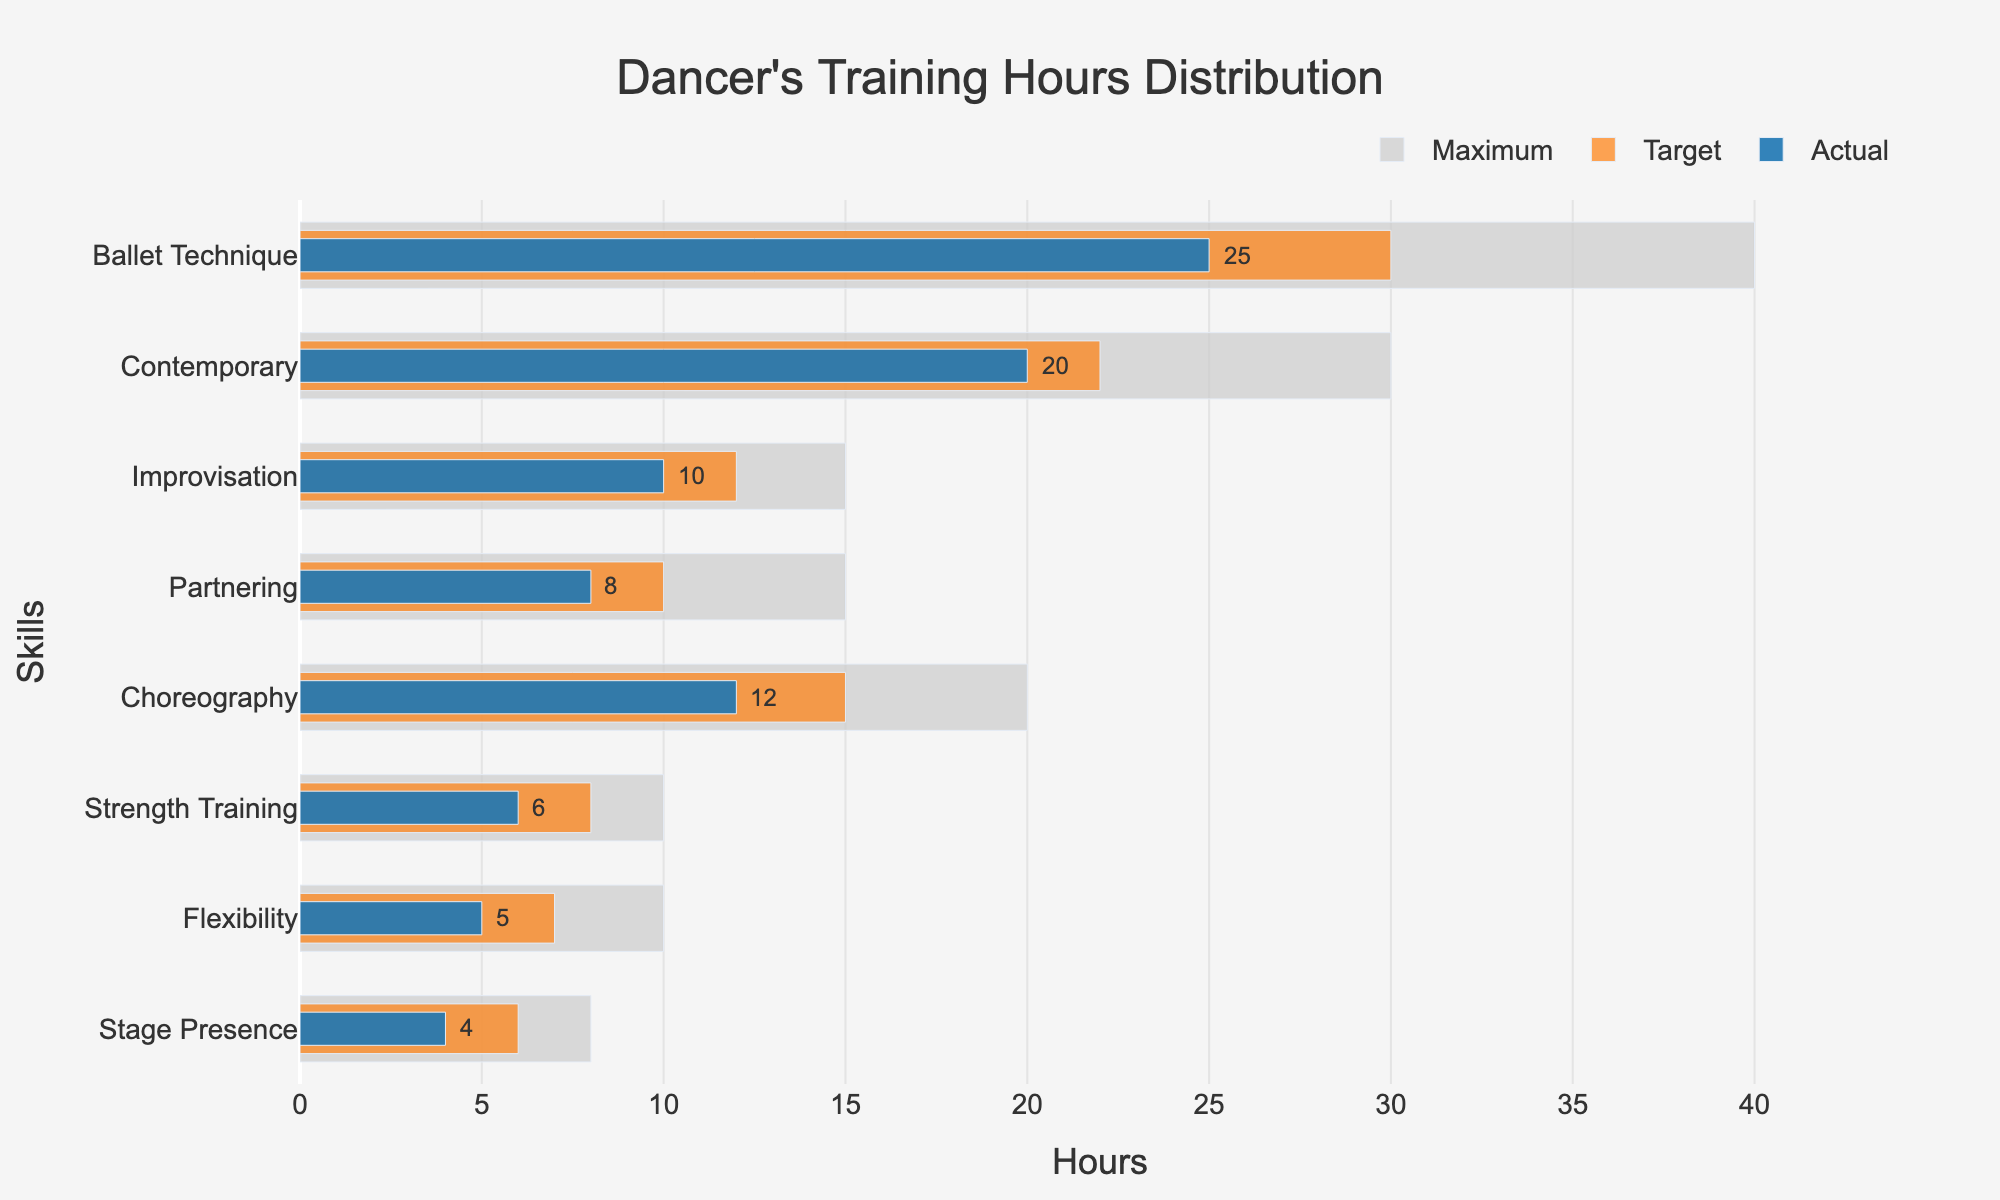What's the title of the figure? The title is located at the top center of the figure. It provides a summary of what the figure represents.
Answer: Dancer's Training Hours Distribution What are the skills evaluated in the figure? The skills are listed along the y-axis of the figure. You can read them from top to bottom.
Answer: Ballet Technique, Contemporary, Improvisation, Partnering, Choreography, Strength Training, Flexibility, Stage Presence Which skill has the highest target training hours? To determine this, look at the orange bars representing the target values and identify which bar is the longest.
Answer: Ballet Technique What is the difference between the actual and target training hours for Partnering? To calculate the difference, subtract the actual hours from the target hours for Partnering (10 - 8).
Answer: 2 How many training hours are dedicated to Strength Training in reality? Referring to the actual values (blue bars) for Strength Training, you can see how many hours are actually dedicated.
Answer: 6 How do the actual training hours for Stage Presence compare to its maximum possible value? Compare the blue bar (actual) with the gray bar (max) for Stage Presence to see how close it is to the maximum.
Answer: The actual hours (4) are half of the maximum (8) Which skill is furthest from its target in terms of training hours? To find this, calculate the differences between the actual and target values for each skill and identify the largest one. Ballet Technique has the largest difference (30 - 25 = 5 hours).
Answer: Ballet Technique What is the average target training hours across all skills? First, sum up the target hours for all skills (30 + 22 + 12 + 10 + 15 + 8 + 7 + 6), then divide by the number of skills (8).
Answer: 13.75 Which skills have actual training hours greater than or equal to 50% of their maximum values? For each skill, calculate 50% of its maximum value (Max * 0.5) and compare it with the actual hours.
Answer: Ballet Technique, Contemporary, Improvisation, Partnering, Choreography, Strength Training, Flexibility, Stage Presence 